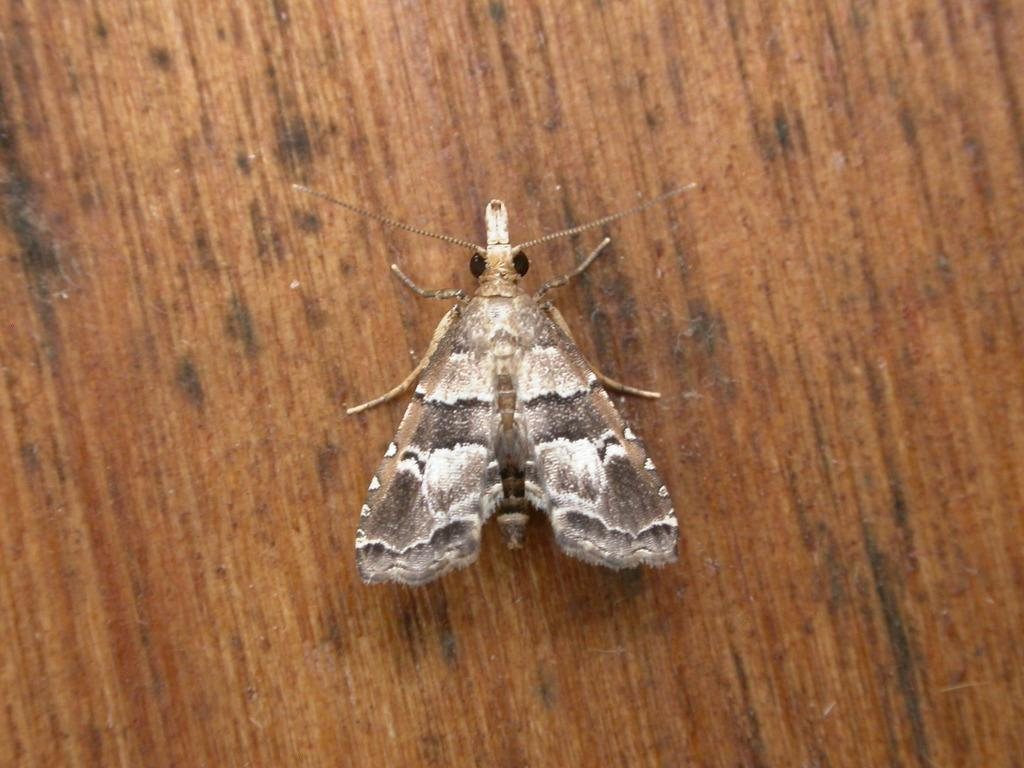What type of creature is present in the image? There is an insect in the image. What is the insect situated on in the image? The insect is on a wooden surface. Where is the insect located in the image? The insect is in the center of the image. How does the bat twist around in the image? There is no bat present in the image, and therefore no such twisting can be observed. 